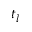Convert formula to latex. <formula><loc_0><loc_0><loc_500><loc_500>t _ { l }</formula> 